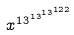Convert formula to latex. <formula><loc_0><loc_0><loc_500><loc_500>x ^ { 1 3 ^ { 1 3 ^ { 1 3 ^ { 1 2 2 } } } }</formula> 